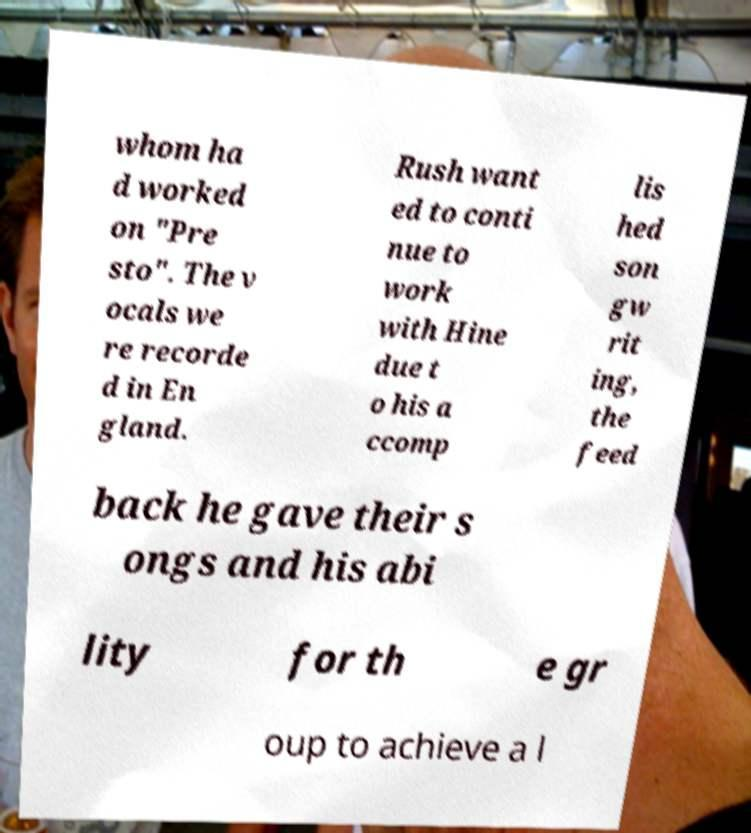There's text embedded in this image that I need extracted. Can you transcribe it verbatim? whom ha d worked on "Pre sto". The v ocals we re recorde d in En gland. Rush want ed to conti nue to work with Hine due t o his a ccomp lis hed son gw rit ing, the feed back he gave their s ongs and his abi lity for th e gr oup to achieve a l 